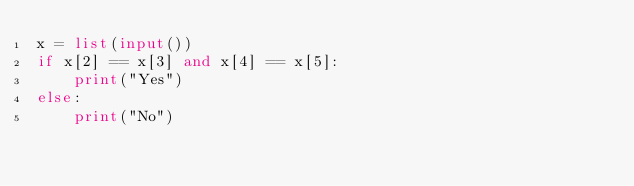Convert code to text. <code><loc_0><loc_0><loc_500><loc_500><_Python_>x = list(input())
if x[2] == x[3] and x[4] == x[5]:
    print("Yes")
else:
    print("No")
</code> 